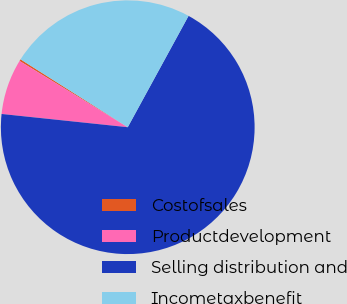Convert chart. <chart><loc_0><loc_0><loc_500><loc_500><pie_chart><fcel>Costofsales<fcel>Productdevelopment<fcel>Selling distribution and<fcel>Incometaxbenefit<nl><fcel>0.24%<fcel>7.08%<fcel>68.71%<fcel>23.97%<nl></chart> 